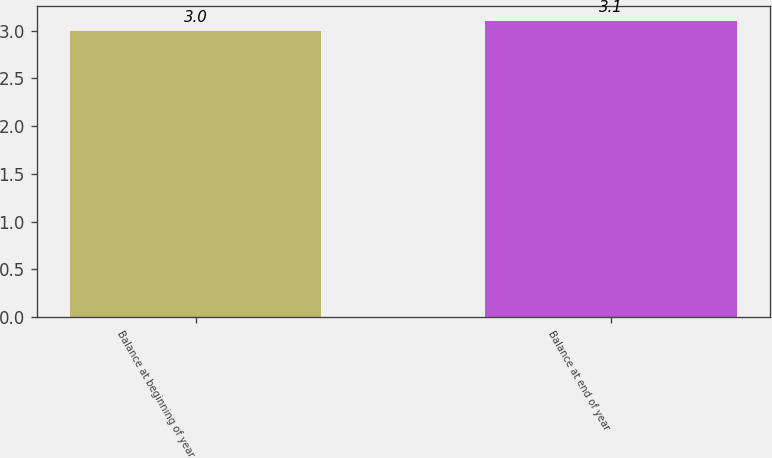Convert chart. <chart><loc_0><loc_0><loc_500><loc_500><bar_chart><fcel>Balance at beginning of year<fcel>Balance at end of year<nl><fcel>3<fcel>3.1<nl></chart> 